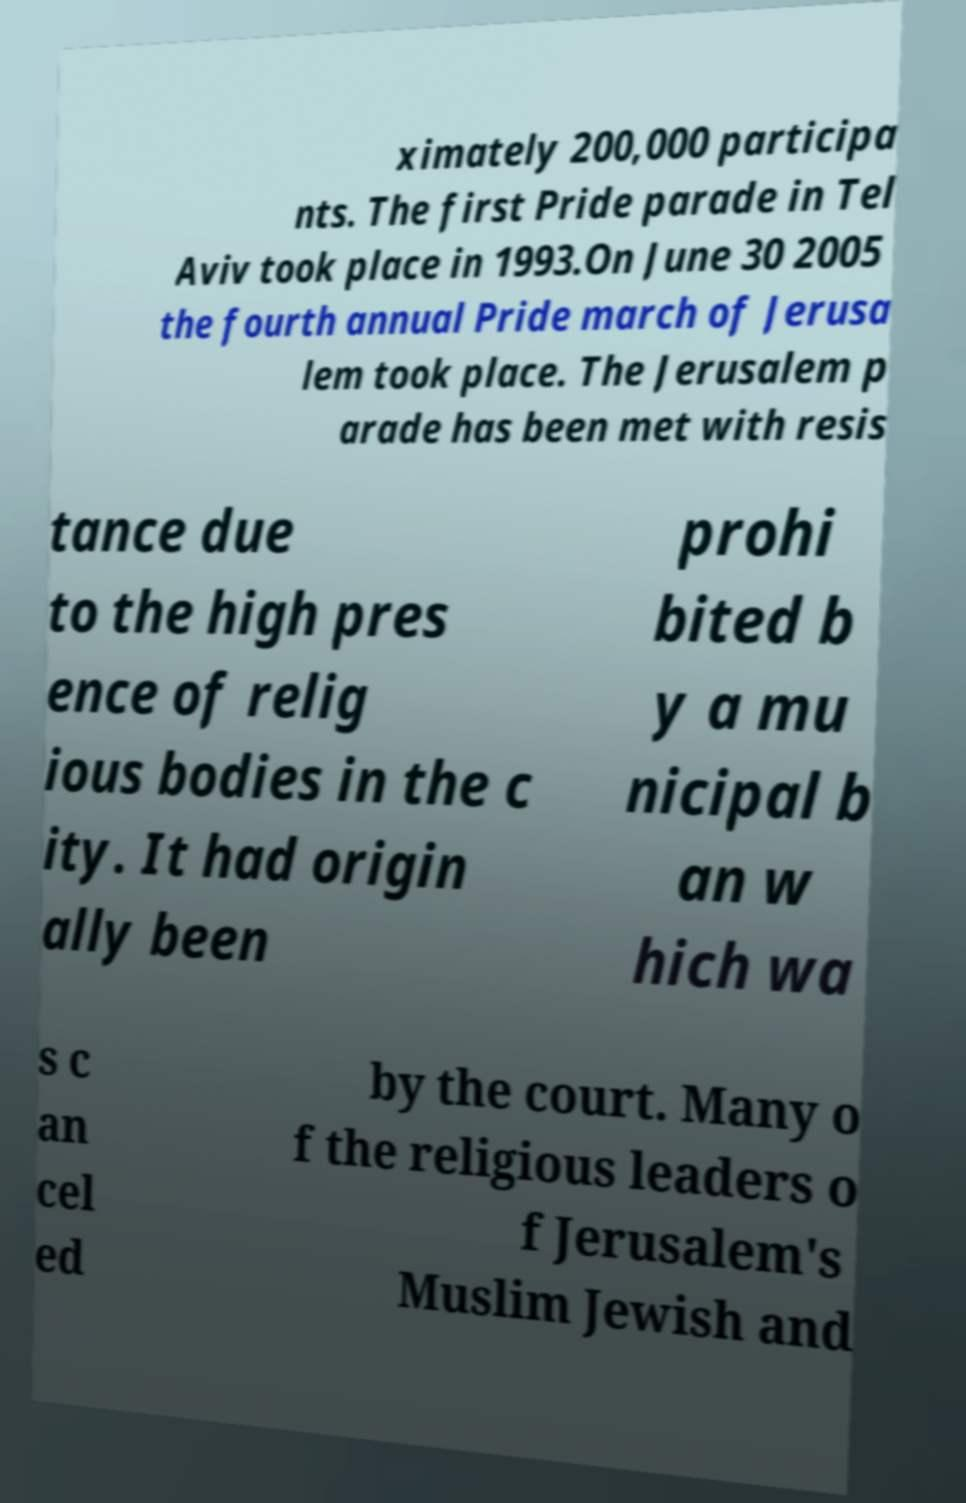Could you assist in decoding the text presented in this image and type it out clearly? ximately 200,000 participa nts. The first Pride parade in Tel Aviv took place in 1993.On June 30 2005 the fourth annual Pride march of Jerusa lem took place. The Jerusalem p arade has been met with resis tance due to the high pres ence of relig ious bodies in the c ity. It had origin ally been prohi bited b y a mu nicipal b an w hich wa s c an cel ed by the court. Many o f the religious leaders o f Jerusalem's Muslim Jewish and 